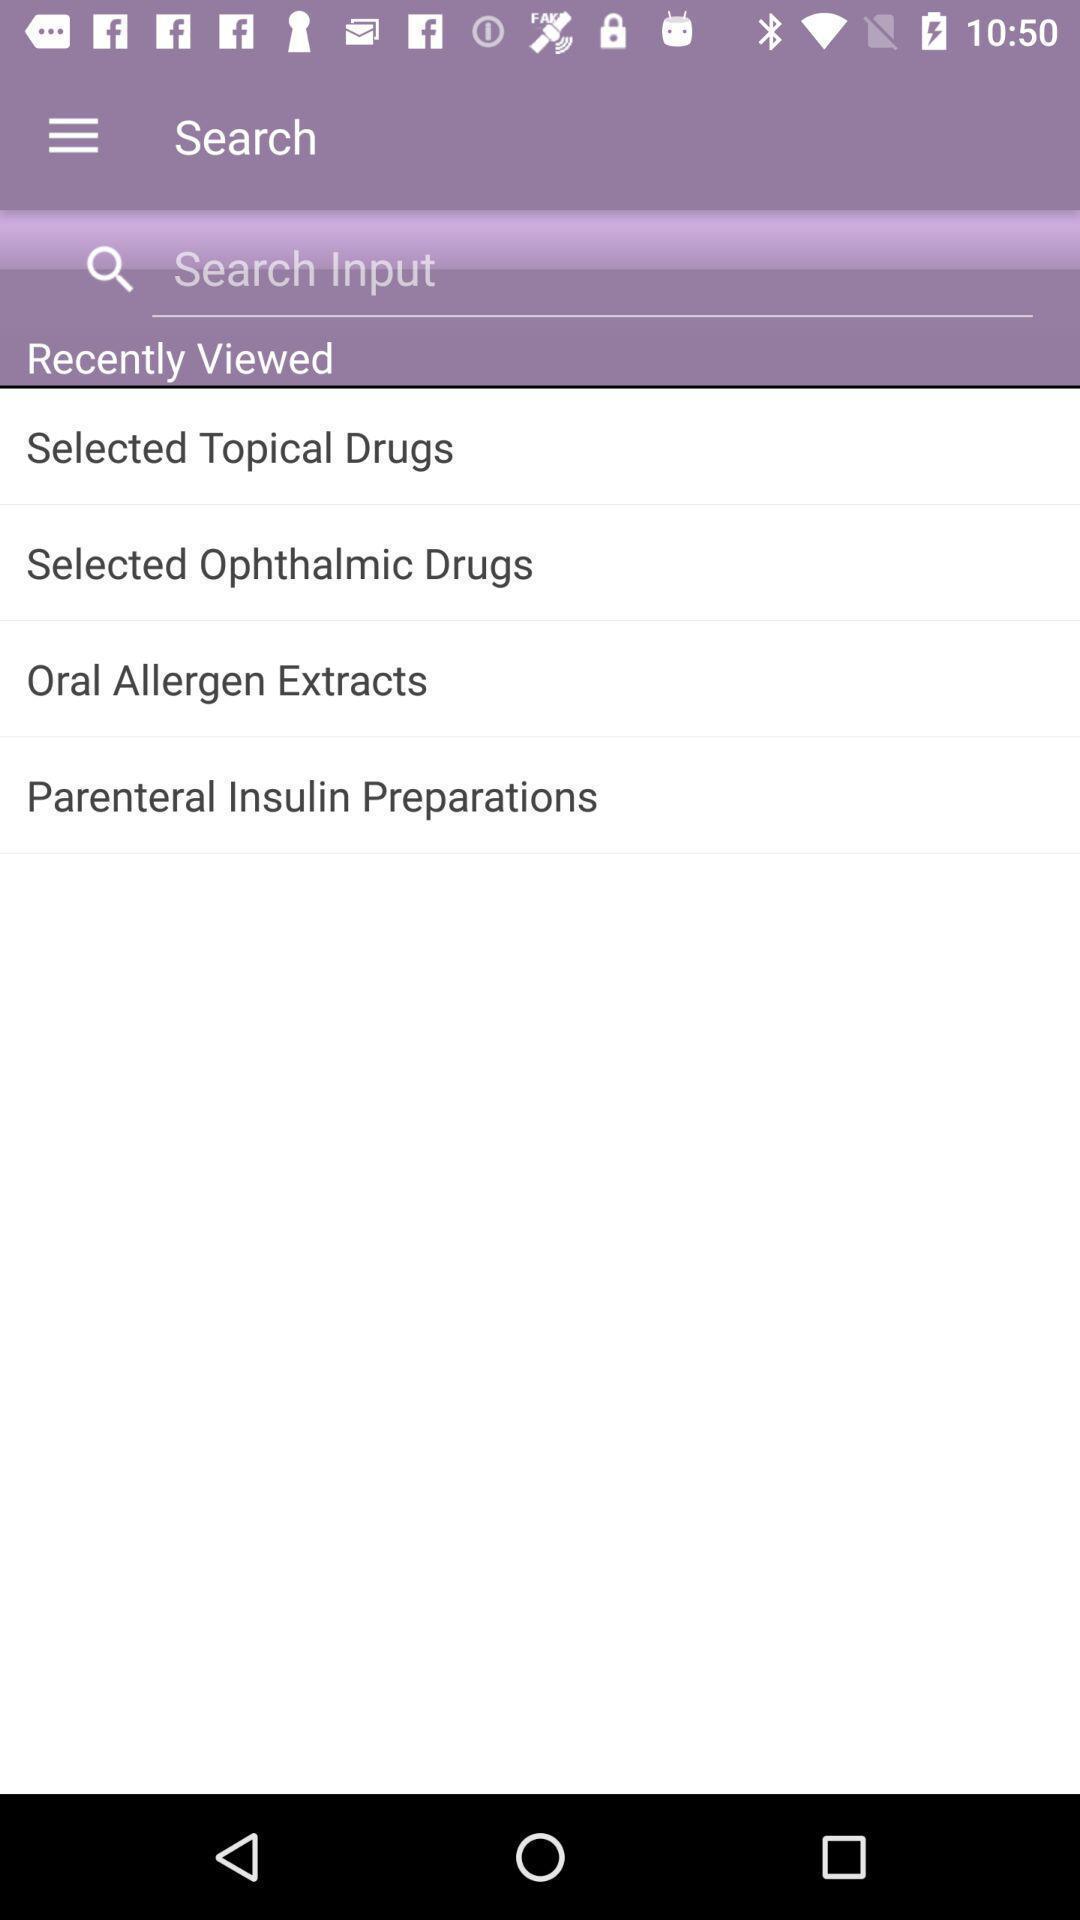Give me a summary of this screen capture. Search page with recently viewed. 